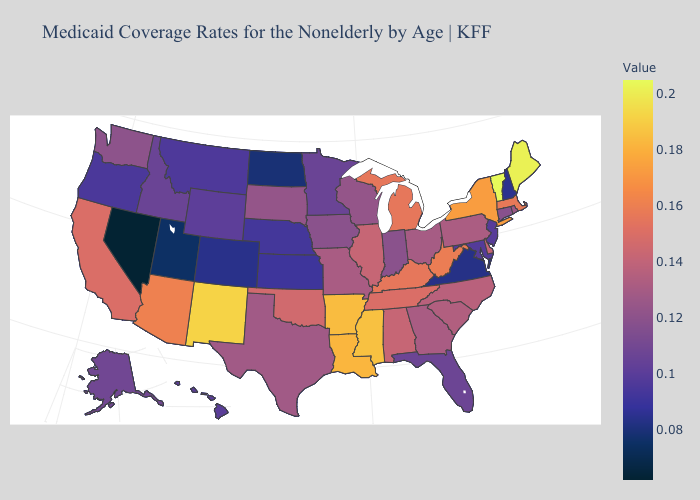Among the states that border Oregon , which have the highest value?
Answer briefly. California. Does Virginia have the highest value in the USA?
Be succinct. No. Does Arizona have the highest value in the USA?
Concise answer only. No. Which states have the highest value in the USA?
Write a very short answer. Vermont. Among the states that border Nevada , does Utah have the lowest value?
Short answer required. Yes. Which states have the lowest value in the USA?
Short answer required. Nevada. Does Nebraska have the lowest value in the MidWest?
Quick response, please. No. 